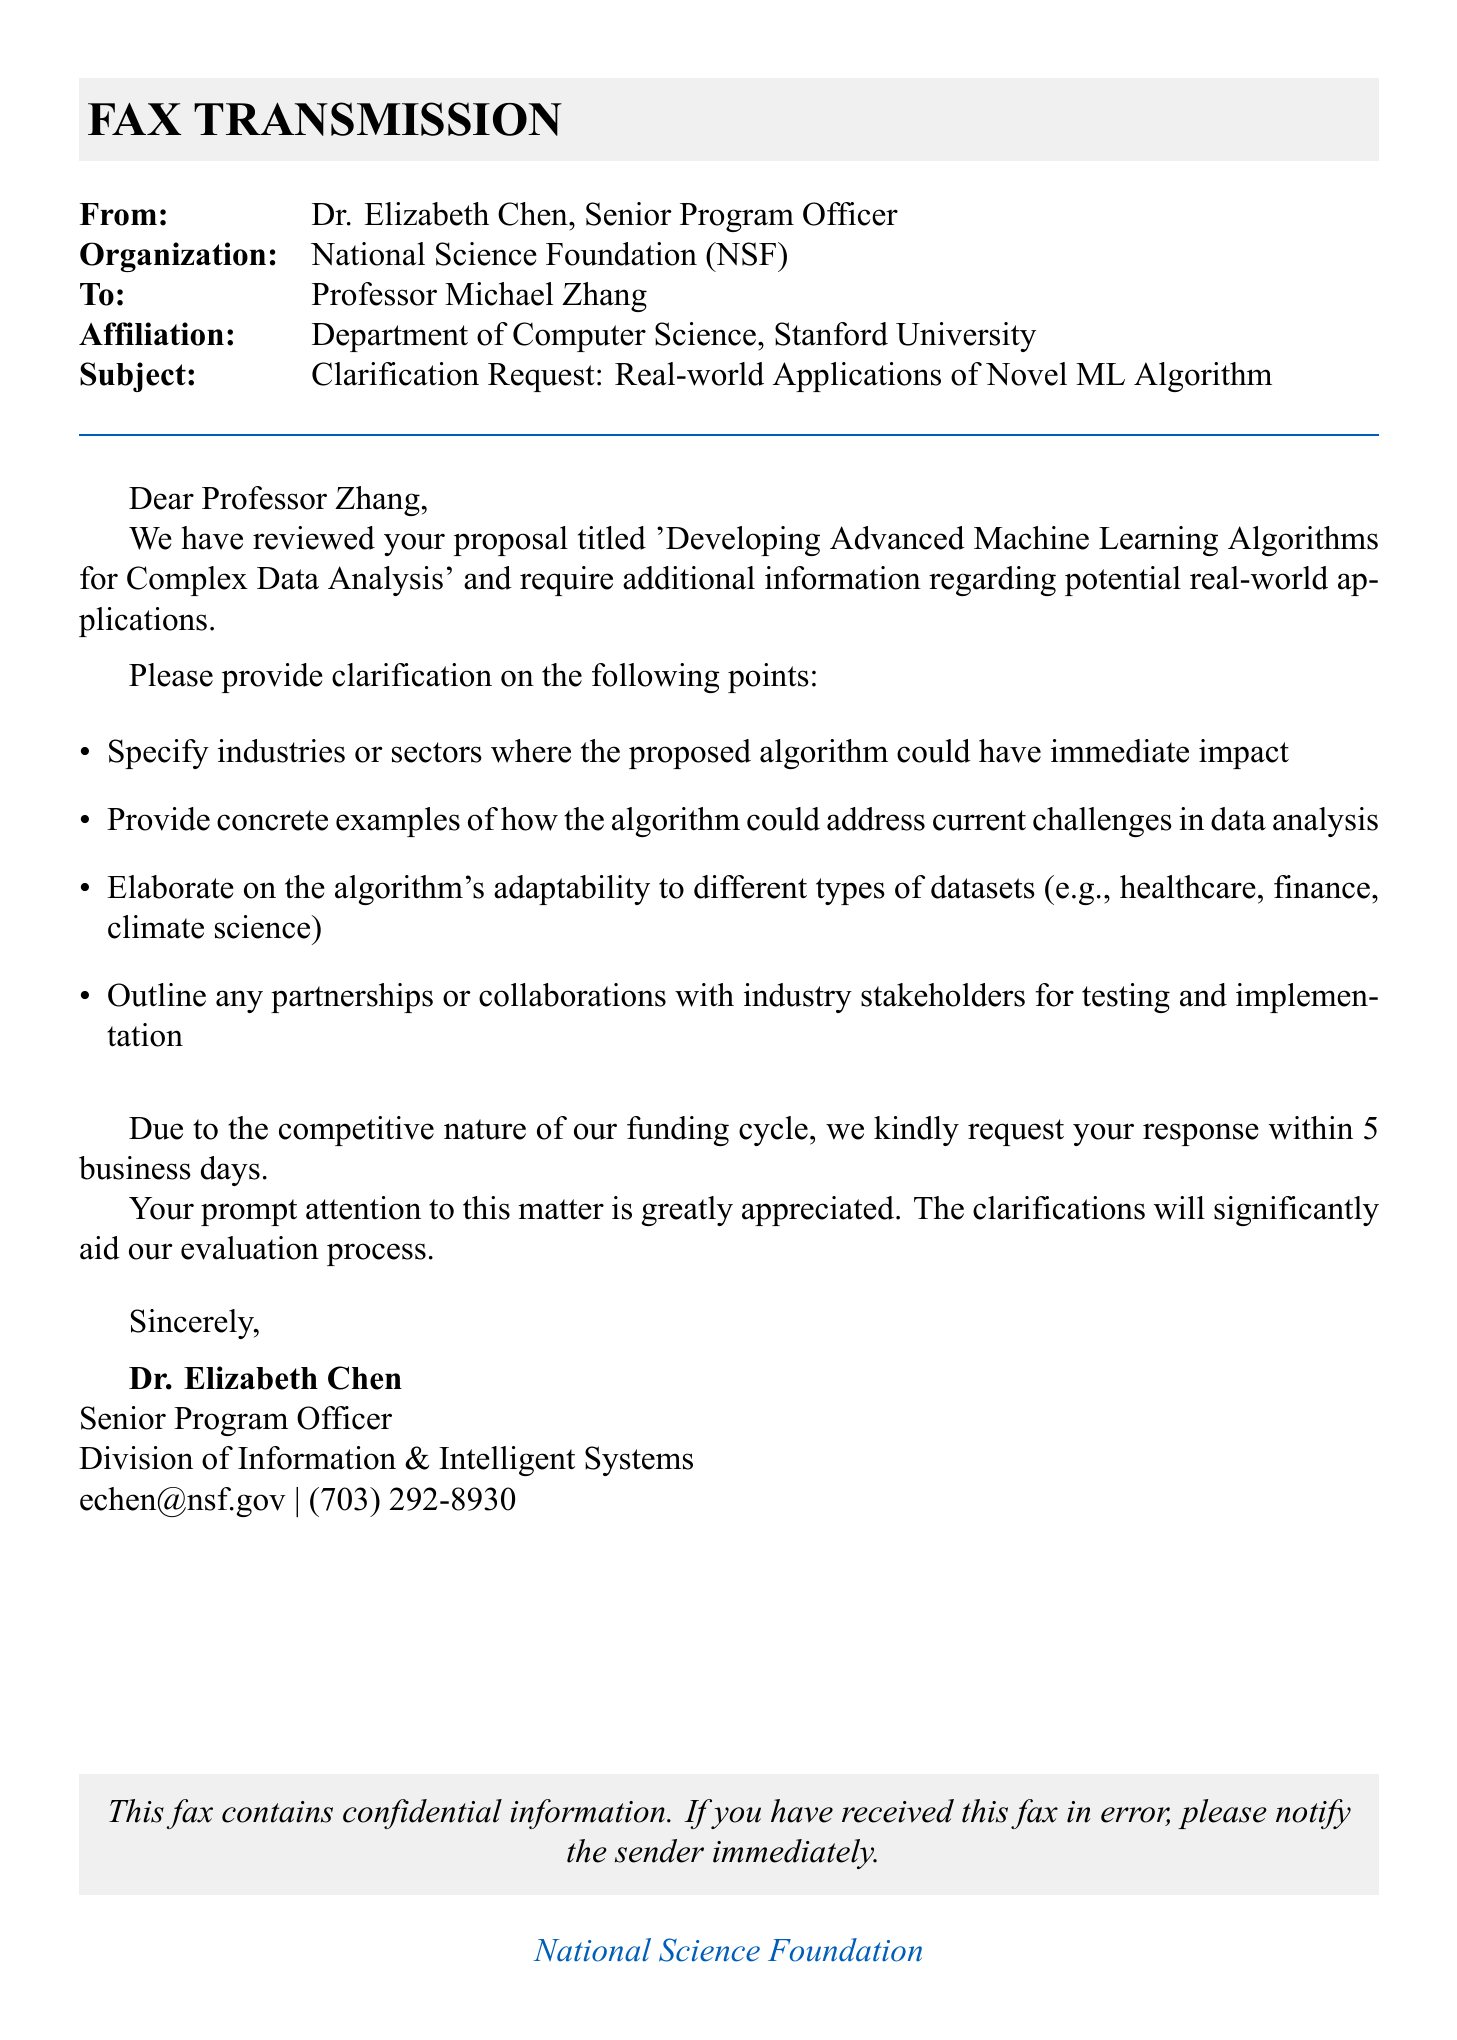What is the name of the funding agency? The funding agency is mentioned at the bottom of the document in the footer as the National Science Foundation.
Answer: National Science Foundation Who is the sender of the fax? The sender, Dr. Elizabeth Chen, is identified at the beginning of the document.
Answer: Dr. Elizabeth Chen What is the subject of the fax? The subject is specifically outlined in the header section of the fax as a request for clarification on a certain topic.
Answer: Clarification Request: Real-world Applications of Novel ML Algorithm How many business days does Professor Zhang have to respond? The document states the response time required from the recipient explicitly.
Answer: 5 business days What department is Professor Zhang affiliated with? The fax indicates Professor Zhang's affiliation in the addressing section.
Answer: Department of Computer Science What is the main purpose of the fax? The primary purpose is to obtain additional information regarding the proposal submitted by Professor Zhang.
Answer: Clarification on potential real-world applications List one point on which clarification is requested. The document outlines several points requiring clarification; a specific example is provided.
Answer: Specify industries or sectors What type of collaborations does the sender inquire about? The document asks the recipient to elaborate on potential partnerships in a specific context.
Answer: Partnerships or collaborations with industry stakeholders What is Dr. Chen's title? The title of Dr. Chen is provided in the closing section of the fax.
Answer: Senior Program Officer 